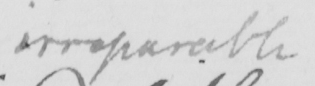Transcribe the text shown in this historical manuscript line. irreparable 